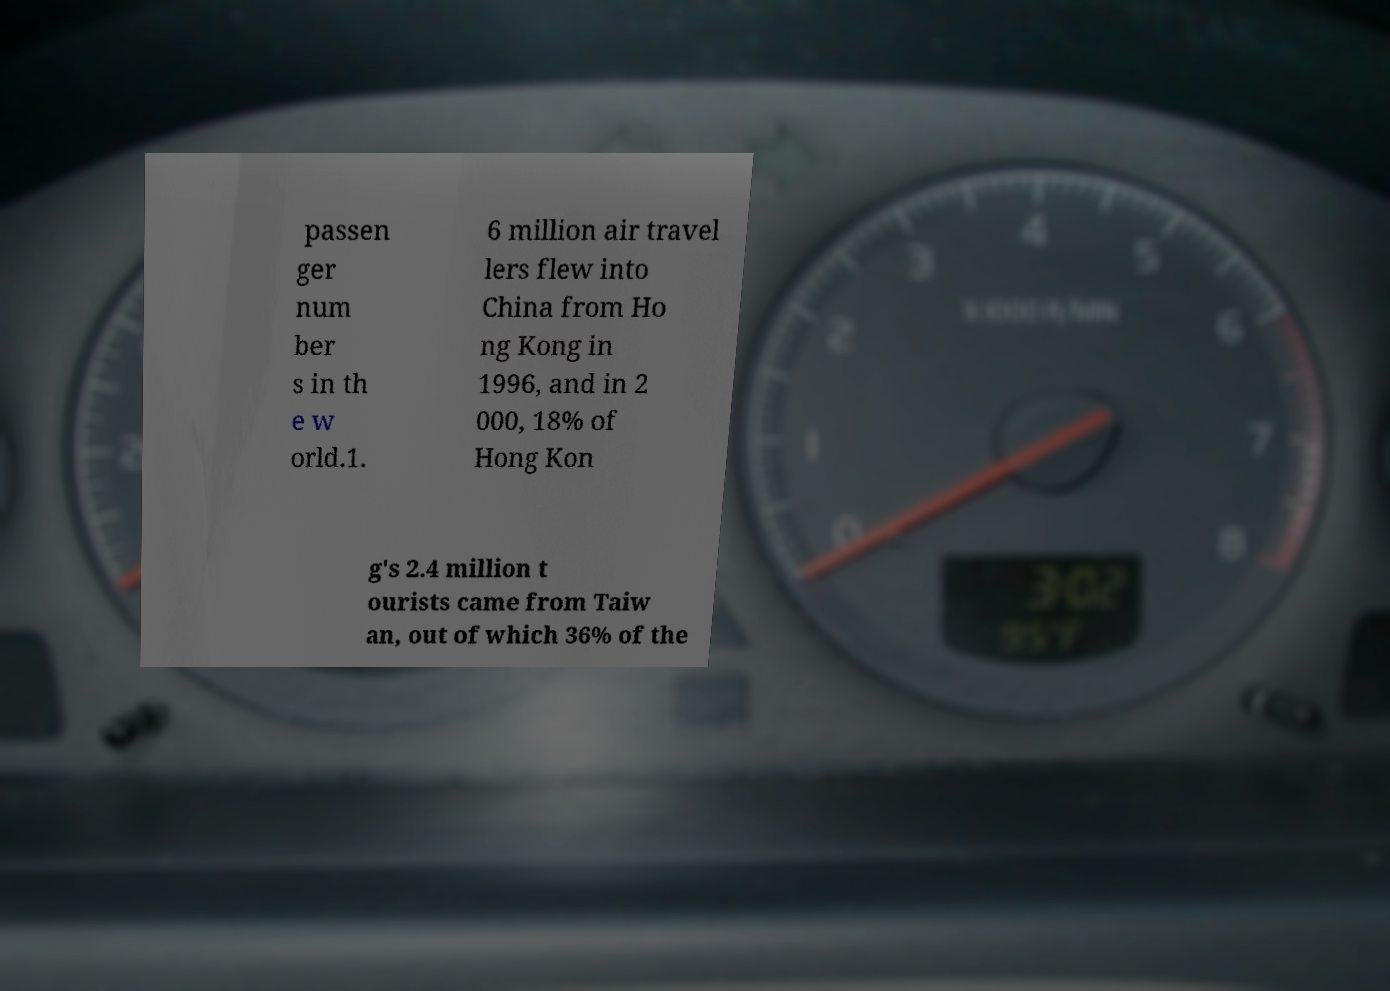Please read and relay the text visible in this image. What does it say? passen ger num ber s in th e w orld.1. 6 million air travel lers flew into China from Ho ng Kong in 1996, and in 2 000, 18% of Hong Kon g's 2.4 million t ourists came from Taiw an, out of which 36% of the 